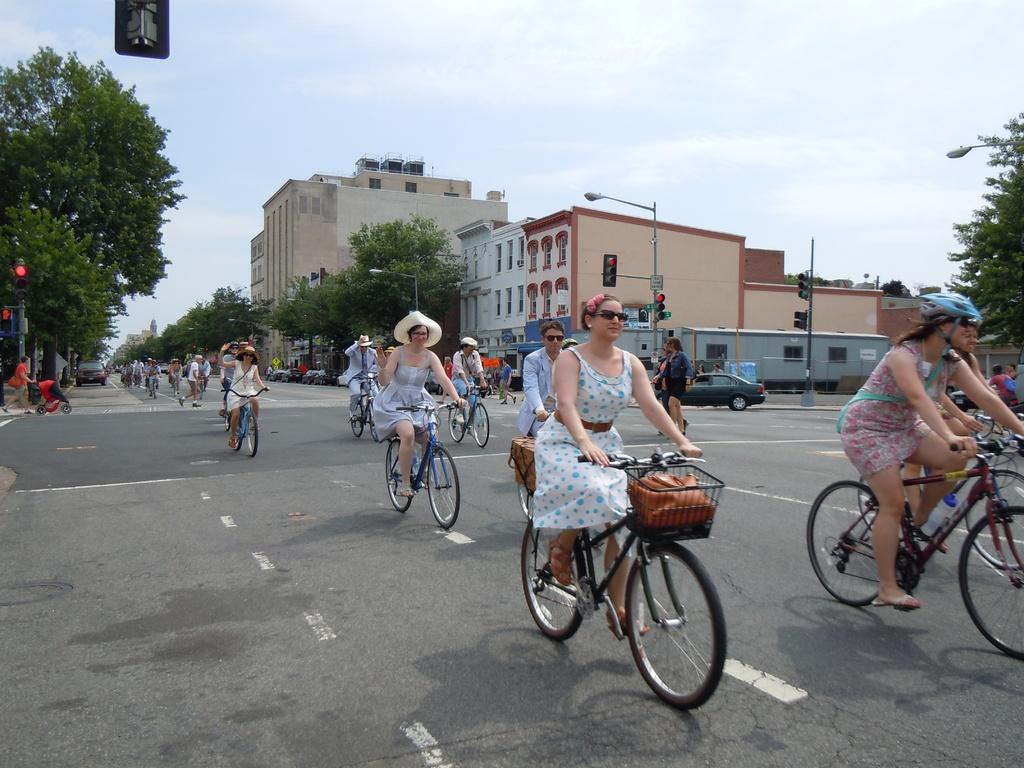How would you summarize this image in a sentence or two? In this picture There are many people who are riding a bicycle. There is a car, traffic signal , street light, trees, buildings. There is a woman carrying a baby carrier on the road. Sky is blue in color and cloudy. 